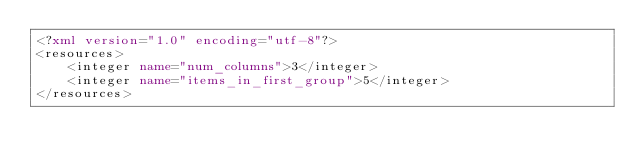<code> <loc_0><loc_0><loc_500><loc_500><_XML_><?xml version="1.0" encoding="utf-8"?>
<resources>
    <integer name="num_columns">3</integer>
    <integer name="items_in_first_group">5</integer>
</resources></code> 